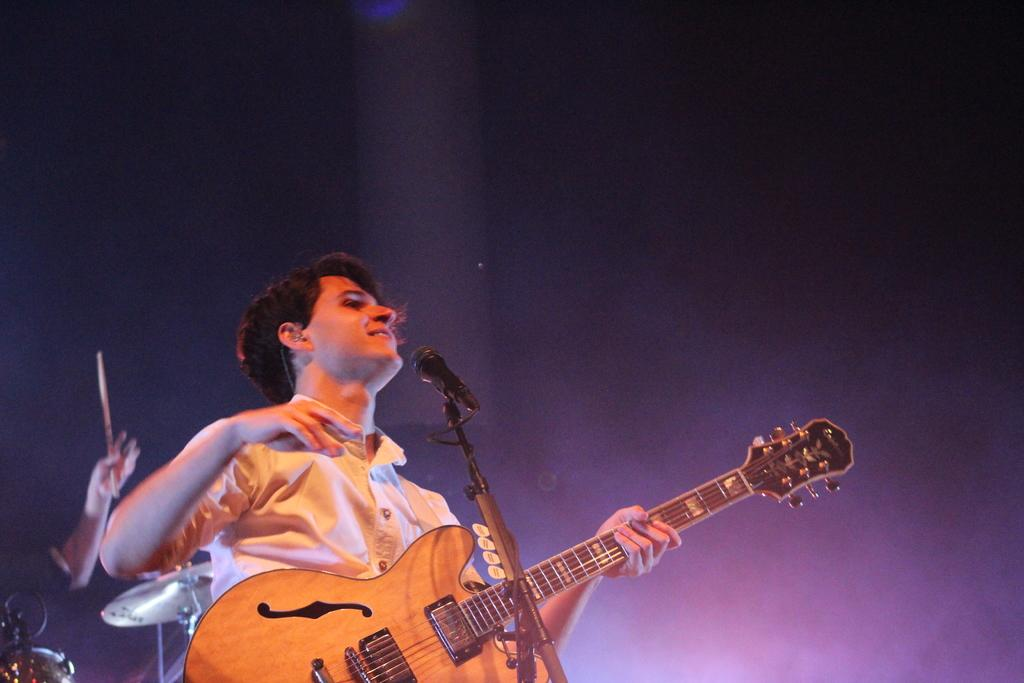What is the man in the image doing? The man in the image is playing a guitar. What is the man behind the microphone using? The man is using a microphone with a stand. What else can be seen in the image related to music? There are musical instruments visible in the image. What is the man holding in his hand? The man is holding a stick in his hand. What type of lettuce is growing in the hole in the image? There is no hole or lettuce present in the image. 